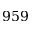<formula> <loc_0><loc_0><loc_500><loc_500>9 5 9</formula> 